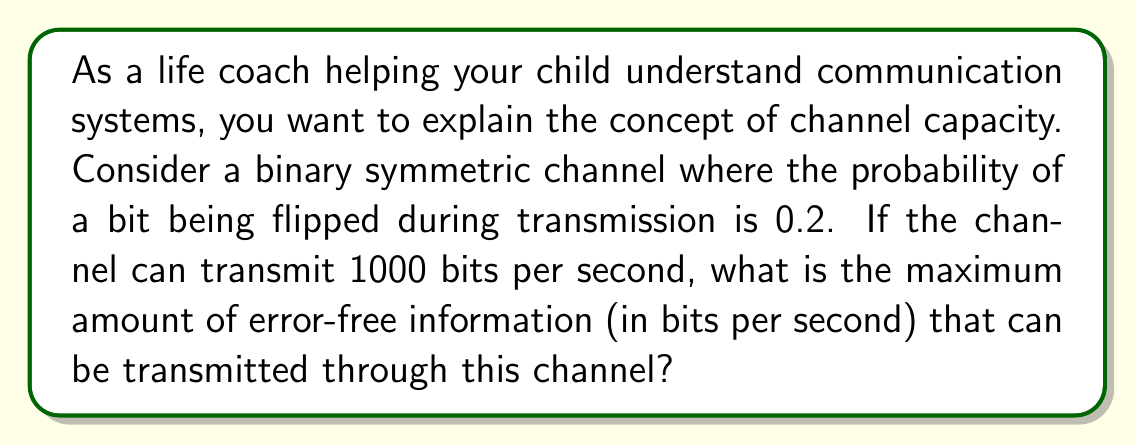Provide a solution to this math problem. To solve this problem, we'll use the channel capacity formula for a binary symmetric channel:

$$C = R(1 - H(p))$$

Where:
$C$ is the channel capacity in bits per second
$R$ is the raw bit rate of the channel
$H(p)$ is the binary entropy function
$p$ is the probability of a bit flip

1. First, we calculate the binary entropy function $H(p)$:
   $$H(p) = -p \log_2(p) - (1-p) \log_2(1-p)$$
   $$H(0.2) = -0.2 \log_2(0.2) - 0.8 \log_2(0.8)$$
   $$H(0.2) \approx 0.7219$$

2. Now we can plug this value and the given raw bit rate into the channel capacity formula:
   $$C = 1000 \cdot (1 - 0.7219)$$
   $$C = 1000 \cdot 0.2781$$
   $$C = 278.1$$

This result means that out of the 1000 bits transmitted per second, only about 278.1 bits can be guaranteed to be error-free information.
Answer: The maximum amount of error-free information that can be transmitted through this channel is approximately 278.1 bits per second. 